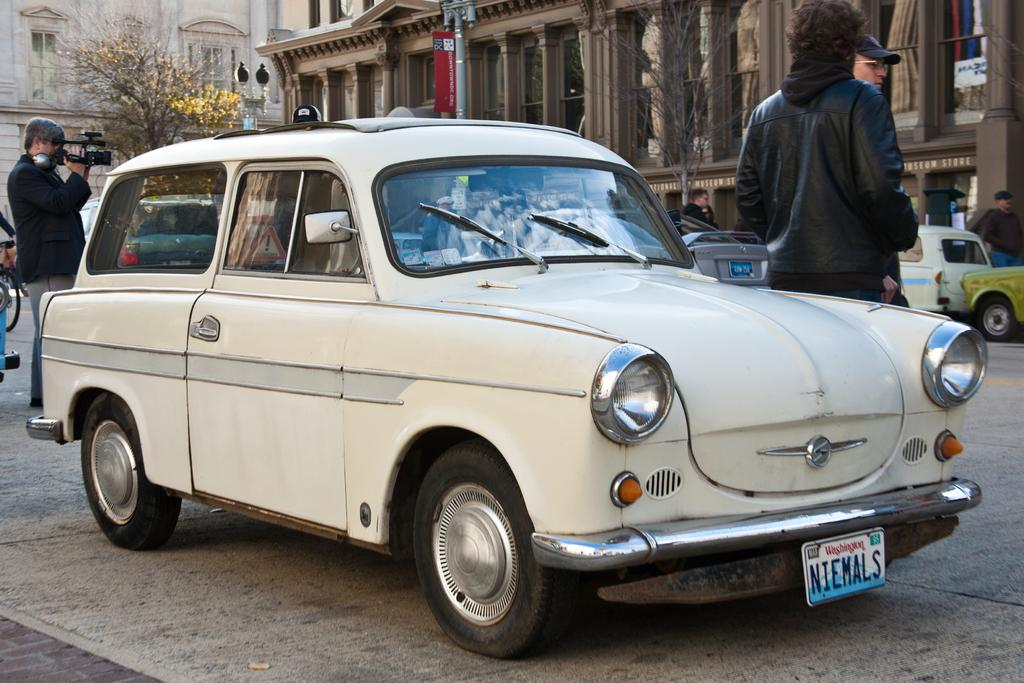What type of vehicle is in the image? There is a white car in the image. What can be seen in the background of the image? There are persons, trees, and buildings in the background of the image. What type of comfort can be found in the tub in the image? There is no tub present in the image, so it is not possible to determine what type of comfort might be found in it. 